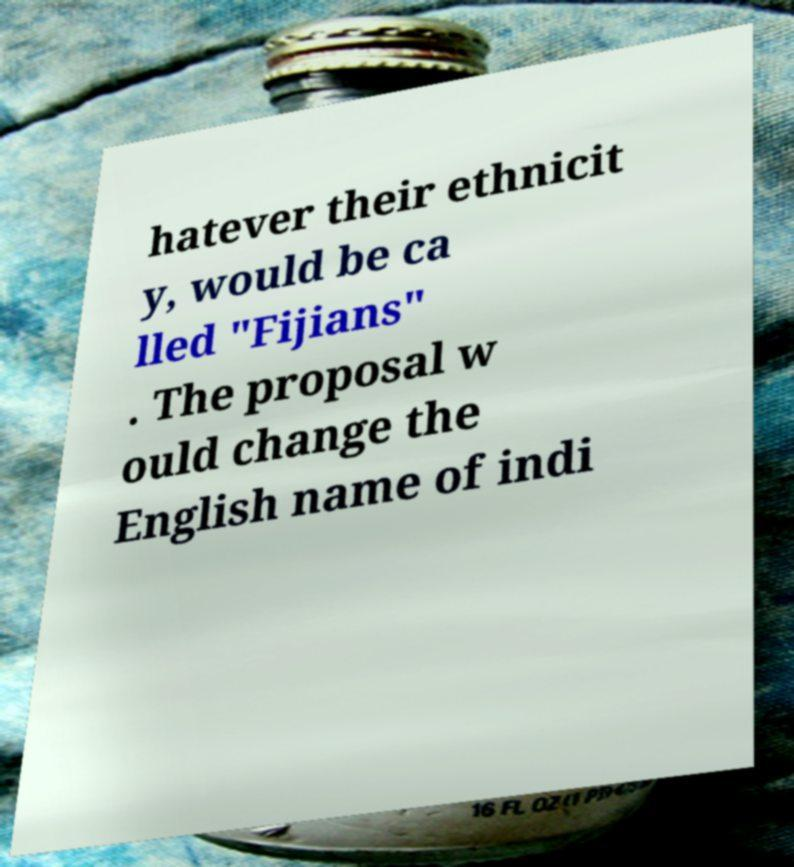Please read and relay the text visible in this image. What does it say? hatever their ethnicit y, would be ca lled "Fijians" . The proposal w ould change the English name of indi 